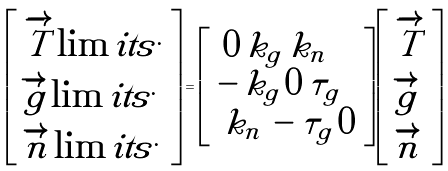<formula> <loc_0><loc_0><loc_500><loc_500>\left [ \begin{array} { l } \overrightarrow { T } \lim i t s ^ { . } \\ \overrightarrow { g } \lim i t s ^ { . } \\ \overrightarrow { n } \lim i t s ^ { . } \\ \end{array} \right ] = \left [ \begin{array} { l } \, 0 \, { k _ { g } } \, { k _ { n } } \\ - \, { k _ { g } } \, 0 \, { \tau _ { g } } \\ \, { k _ { n } } \, - { \tau _ { g } } \, 0 \\ \end{array} \right ] \left [ \begin{array} { l } \overrightarrow { T } \\ \overrightarrow { g } \\ \overrightarrow { n } \\ \end{array} \right ]</formula> 